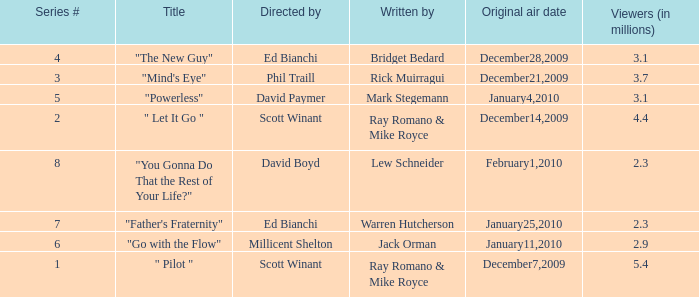How many episodes are written by Lew Schneider? 1.0. 